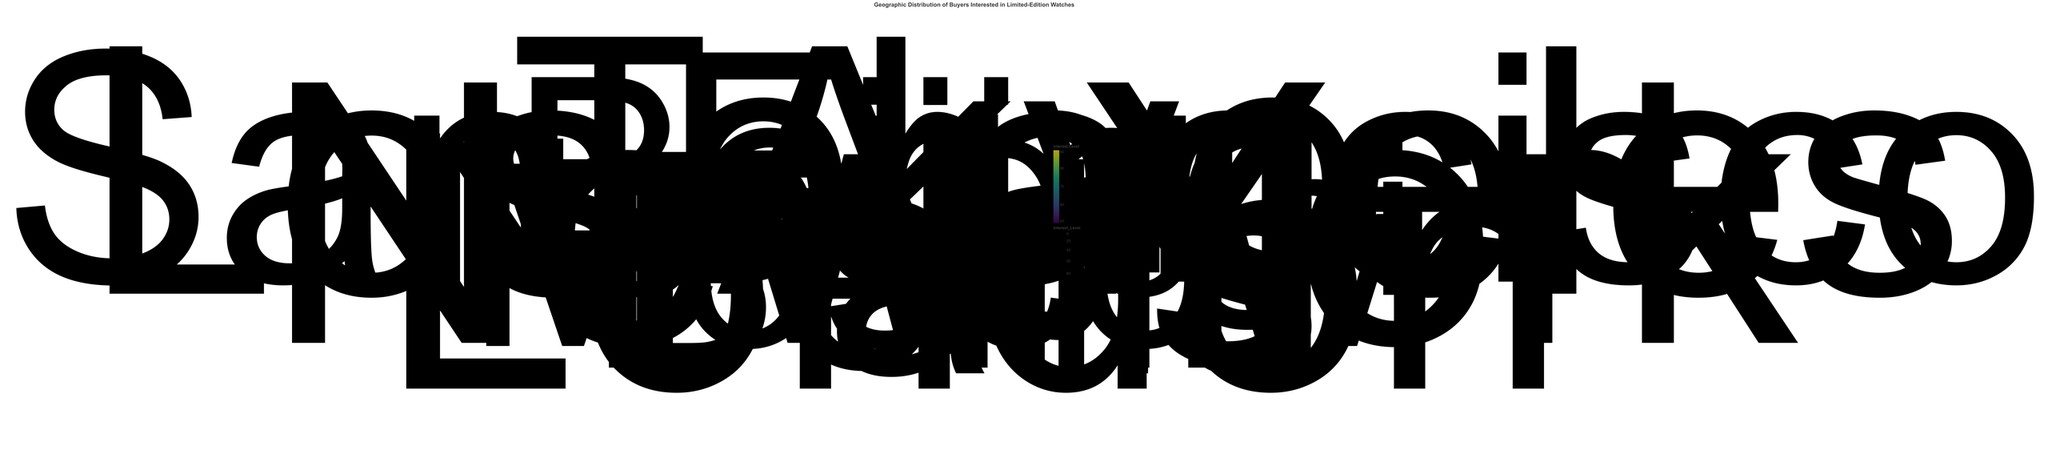What's the title of the figure? Look at the central area where the title is typically placed. It states the main topic or purpose of the chart.
Answer: Geographic Distribution of Buyers Interested in Limited-Edition Watches What is the highest Interest Level and which city does it correspond to? Identify the largest size point and its corresponding tooltip or label.
Answer: 90, New York Which city has an Interest Level of 85 and what is its approximate geographic location? Find the data point with the Interest Level of 85 and check its label. The corresponding city is Los Angeles, located at roughly (34.05 N, -118.24 W).
Answer: Los Angeles What is the Interest Level of the buyers in Tokyo? Refer to the tooltip or label associated with the data point for Tokyo.
Answer: 80 How many cities have an Interest Level greater than 80? Count the number of data points with Interest Levels exceeding 80 by looking at their sizes and colors.
Answer: 3 (New York, Los Angeles, London) Which city is indicated by the point closest to the center of the chart? Identify the point that is closest to the origin (0,0) in the polar plot. This is New Delhi.
Answer: New Delhi Compare the Interest Levels of buyers in London and Paris. Which city has a higher Interest Level? Check the tooltips or labels for London and Paris. London has an Interest Level of 88, while Paris has 75, so London is higher.
Answer: London What is the average Interest Level of all the cities shown in the chart? Sum all the Interest Levels: (85 + 90 + 75 + 80 + 70 + 88 + 60 + 65 + 78 + 50) = 741, then divide by the number of cities (10).
Answer: 74.1 Which city is located at approximately (51.50 N, -0.13 W) and what is its Interest Level? Find the point closest to the coordinates (51.50, -0.13). This corresponds to London, which has an Interest Level of 88.
Answer: London, 88 